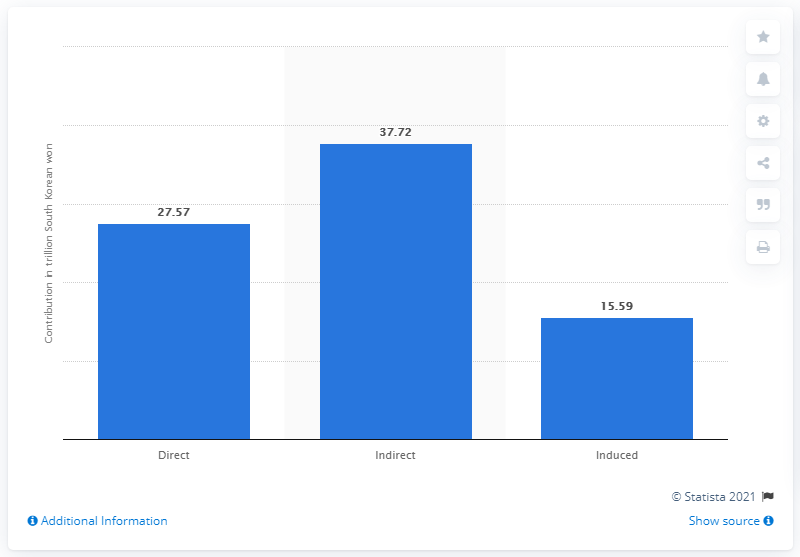Point out several critical features in this image. In 2017, the travel and tourism industry contributed a significant 37.72% to South Korea's Gross Domestic Product (GDP). 